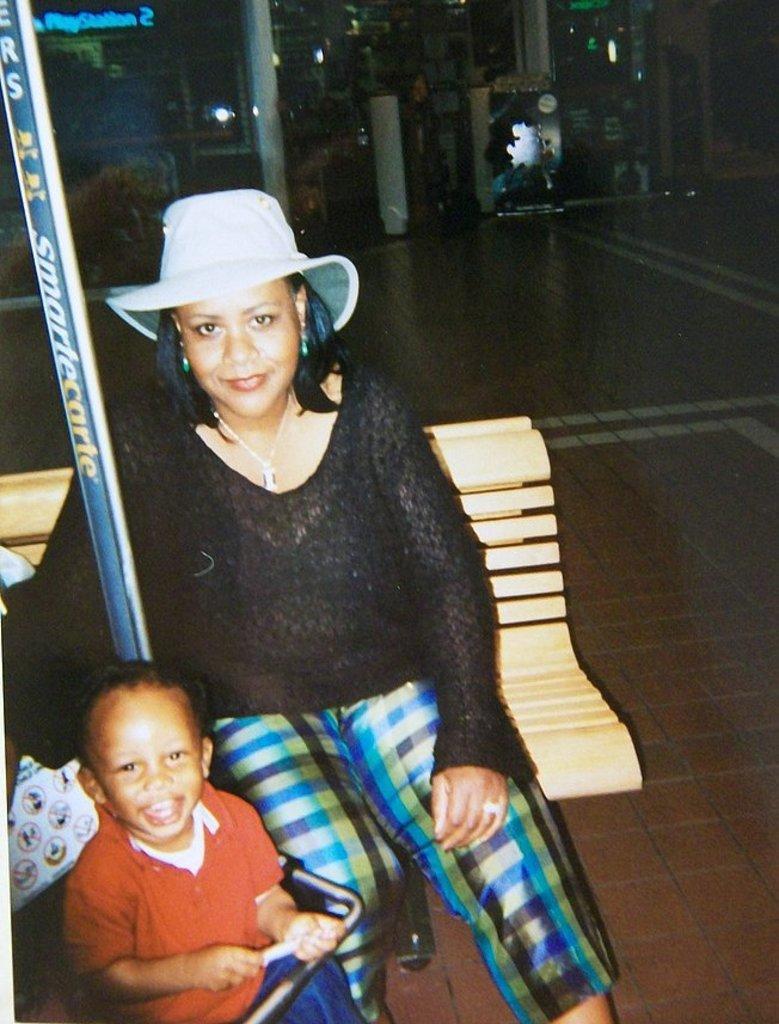Please provide a concise description of this image. In this picture I can see a woman seated on the bench and I can see a boy and looks like a building in the back and woman wore a cap on her head and I can see a bag on the bench on the left side. 